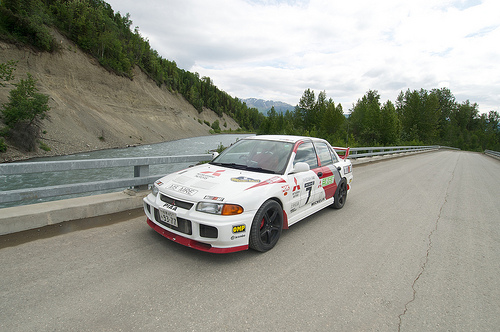<image>
Is there a car to the left of the hill? No. The car is not to the left of the hill. From this viewpoint, they have a different horizontal relationship. Where is the car in relation to the road? Is it behind the road? No. The car is not behind the road. From this viewpoint, the car appears to be positioned elsewhere in the scene. 